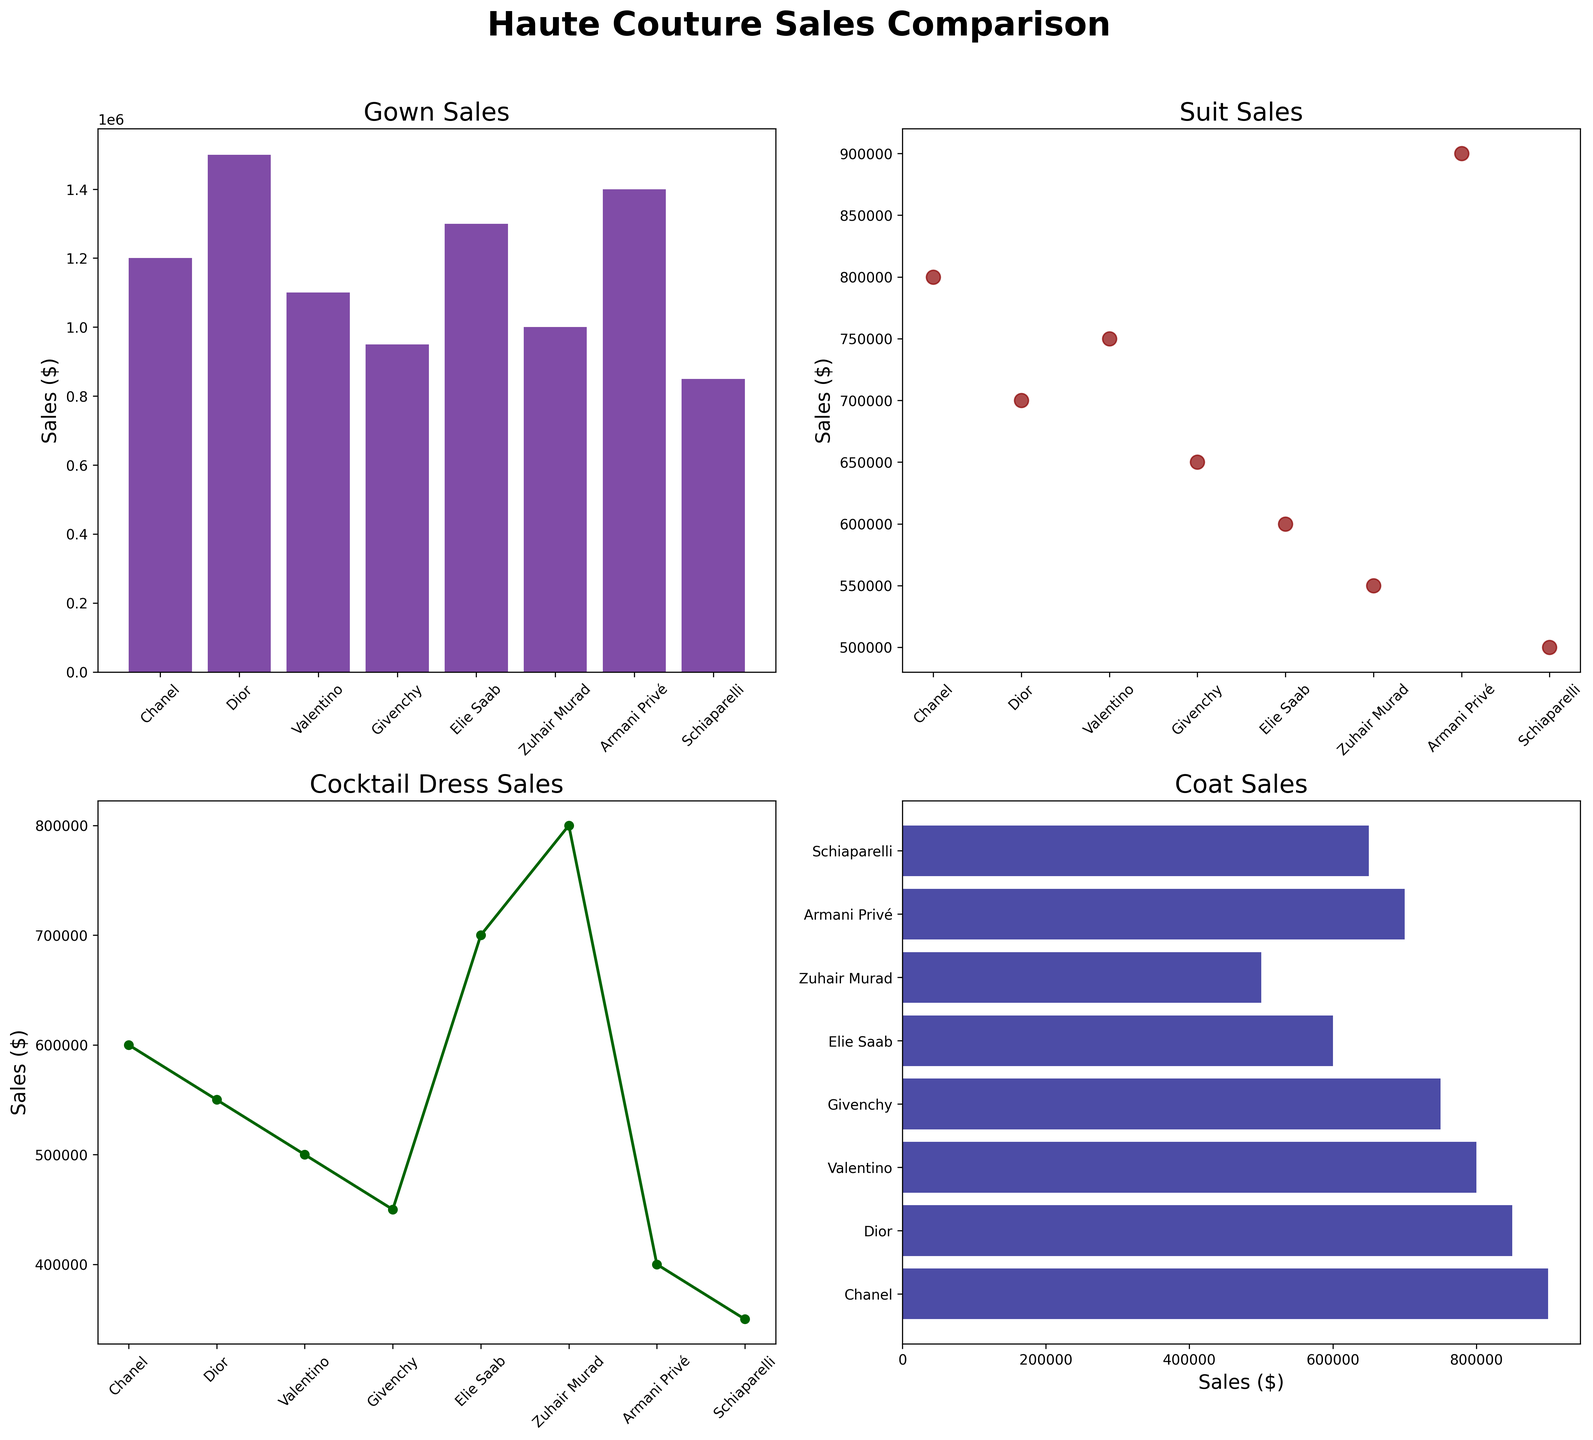Which fashion house has the highest sales in gowns? Based on the bar chart for Gown Sales, the highest bar corresponds to Dior.
Answer: Dior What is the sales difference between the fashion house with the highest coat sales and the one with the lowest? The highest coat sales are for Chanel ($900,000), and the lowest are for Schiaparelli ($650,000). The difference is $900,000 - $650,000 = $250,000.
Answer: $250,000 Which fashion house has the lowest sales in cocktail dresses? Based on the line plot for Cocktail Dress Sales, Schiaparelli has the lowest point.
Answer: Schiaparelli How does Chanel's sales in suits compare to Valentino's? By looking at the scatter plot for Suit Sales, Chanel's dot is at $800,000 while Valentino's is at $750,000. Chanel's sales are $50,000 higher than Valentino's.
Answer: Chanel's sales are higher In which type of garment does Elie Saab have the highest sales? Referring to all subplots, Elie Saab's highest sales are in Gowns ($1,300,000).
Answer: Gowns What's the total sales for Givenchy across all garment types? Adding the values from the four charts for Givenchy: $950,000 (Gowns) + $650,000 (Suits) + $450,000 (Cocktail Dresses) + $750,000 (Coats) = $2,800,000.
Answer: $2,800,000 Between Armani Privé and Zuhair Murad, which has higher cocktail dress sales, and by how much? Armani Privé has sales of $400,000, and Zuhair Murad has $800,000 in cocktail dresses. So, Zuhair Murad has higher sales by $800,000 - $400,000 = $400,000.
Answer: Zuhair Murad, $400,000 How do Total sales of coats for Dior and Valentino compare? Dior's coat sales are $850,000, and Valentino's are $800,000. Dior's coat sales are higher by $850,000 - $800,000 = $50,000.
Answer: Dior is higher by $50,000 What is the pattern for suit sales across different fashion houses as shown in the scatter plot? The scatter plot shows a declining pattern from the highest sales (Armani Privé) to the lowest sales (Schiaparelli).
Answer: Declining pattern 